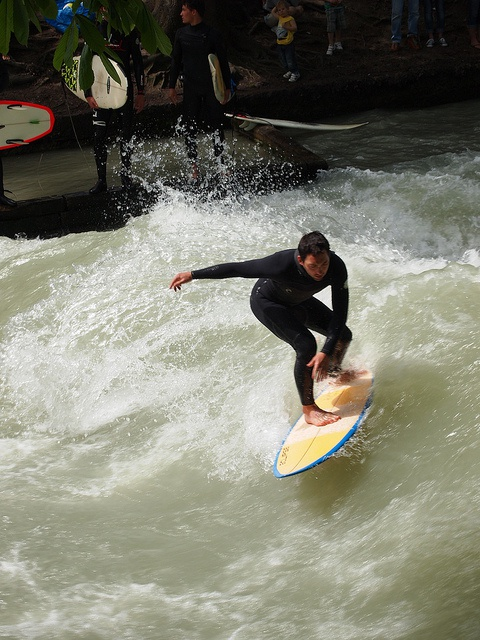Describe the objects in this image and their specific colors. I can see people in black, maroon, lightgray, and brown tones, people in black, gray, maroon, and darkgray tones, surfboard in black, khaki, lightgray, gray, and tan tones, people in black, gray, maroon, and darkgray tones, and surfboard in black, tan, and gray tones in this image. 